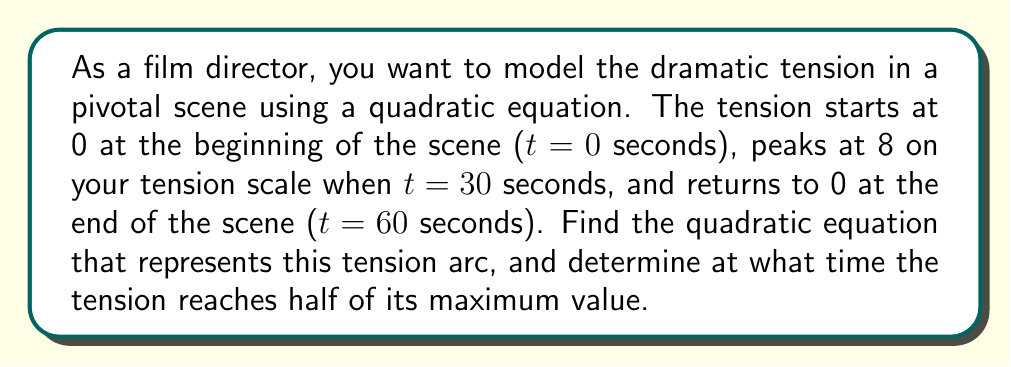Teach me how to tackle this problem. 1) Let's define our quadratic equation as $f(t) = at^2 + bt + c$, where $f(t)$ represents the tension at time $t$.

2) We have three points to work with:
   (0, 0): $f(0) = c = 0$
   (30, 8): $f(30) = a(30)^2 + b(30) + 0 = 8$
   (60, 0): $f(60) = a(60)^2 + b(60) + 0 = 0$

3) From the first point, we know $c = 0$. Our equation is now $f(t) = at^2 + bt$.

4) Using the other two points:
   $900a + 30b = 8$  (from t=30)
   $3600a + 60b = 0$ (from t=60)

5) Multiply the first equation by 4:
   $3600a + 120b = 32$
   $3600a + 60b = 0$

6) Subtracting these equations:
   $60b = 32$
   $b = \frac{16}{30} = \frac{8}{15}$

7) Substitute this back into $3600a + 60b = 0$:
   $3600a + 60(\frac{8}{15}) = 0$
   $3600a = -32$
   $a = -\frac{1}{112.5} = -\frac{2}{225}$

8) Our final equation is:
   $f(t) = -\frac{2}{225}t^2 + \frac{8}{15}t$

9) To find when tension is half the maximum:
   $f(t) = 4 = -\frac{2}{225}t^2 + \frac{8}{15}t$

10) Multiply all terms by 225:
    $900 = -2t^2 + 120t$
    $2t^2 - 120t + 900 = 0$

11) Use the quadratic formula: $t = \frac{-b \pm \sqrt{b^2 - 4ac}}{2a}$
    $t = \frac{120 \pm \sqrt{14400 - 7200}}{4} = \frac{120 \pm \sqrt{7200}}{4} = \frac{120 \pm 60\sqrt{2}}{4}$

12) This gives us two solutions: $t = 30 + 15\sqrt{2}$ or $t = 30 - 15\sqrt{2}$

13) Since we're looking for the time before the peak, we use $t = 30 - 15\sqrt{2}$ seconds.
Answer: $f(t) = -\frac{2}{225}t^2 + \frac{8}{15}t$; $30 - 15\sqrt{2}$ seconds 